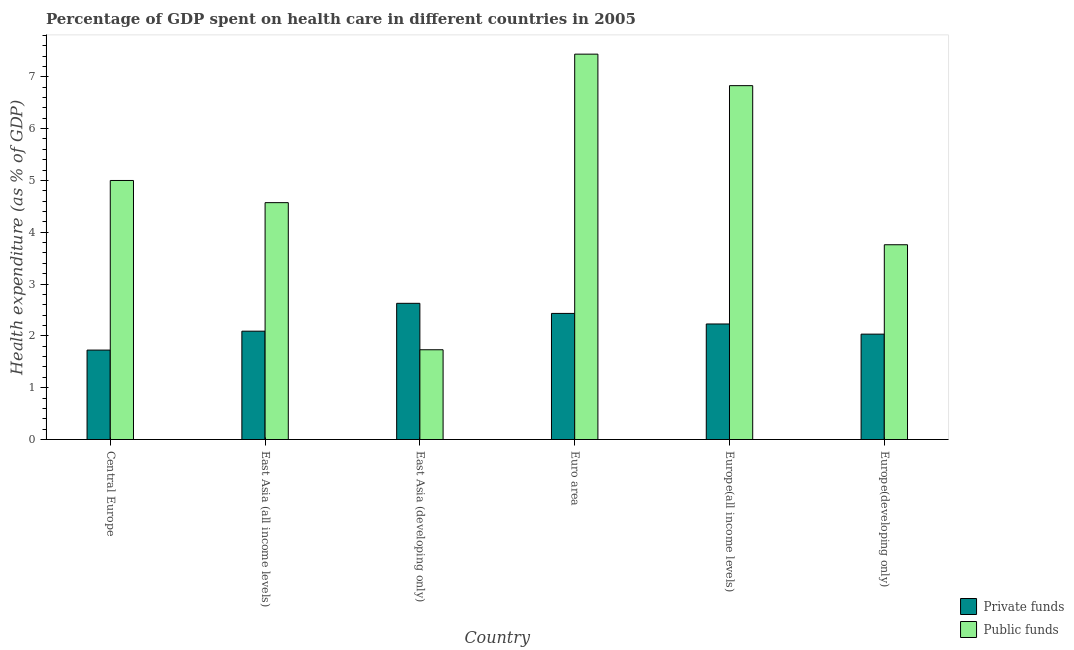How many different coloured bars are there?
Offer a terse response. 2. How many bars are there on the 1st tick from the right?
Make the answer very short. 2. What is the label of the 5th group of bars from the left?
Offer a very short reply. Europe(all income levels). In how many cases, is the number of bars for a given country not equal to the number of legend labels?
Your response must be concise. 0. What is the amount of public funds spent in healthcare in Europe(all income levels)?
Your answer should be compact. 6.83. Across all countries, what is the maximum amount of public funds spent in healthcare?
Give a very brief answer. 7.44. Across all countries, what is the minimum amount of private funds spent in healthcare?
Your answer should be very brief. 1.73. In which country was the amount of private funds spent in healthcare maximum?
Offer a very short reply. East Asia (developing only). In which country was the amount of private funds spent in healthcare minimum?
Ensure brevity in your answer.  Central Europe. What is the total amount of public funds spent in healthcare in the graph?
Make the answer very short. 29.33. What is the difference between the amount of private funds spent in healthcare in Central Europe and that in Europe(all income levels)?
Keep it short and to the point. -0.5. What is the difference between the amount of private funds spent in healthcare in East Asia (developing only) and the amount of public funds spent in healthcare in Central Europe?
Your response must be concise. -2.37. What is the average amount of public funds spent in healthcare per country?
Your answer should be very brief. 4.89. What is the difference between the amount of private funds spent in healthcare and amount of public funds spent in healthcare in East Asia (all income levels)?
Make the answer very short. -2.48. What is the ratio of the amount of public funds spent in healthcare in East Asia (developing only) to that in Europe(all income levels)?
Give a very brief answer. 0.25. Is the amount of private funds spent in healthcare in Central Europe less than that in Euro area?
Your response must be concise. Yes. Is the difference between the amount of public funds spent in healthcare in Europe(all income levels) and Europe(developing only) greater than the difference between the amount of private funds spent in healthcare in Europe(all income levels) and Europe(developing only)?
Offer a terse response. Yes. What is the difference between the highest and the second highest amount of private funds spent in healthcare?
Your answer should be compact. 0.19. What is the difference between the highest and the lowest amount of public funds spent in healthcare?
Your answer should be compact. 5.71. What does the 2nd bar from the left in Europe(all income levels) represents?
Provide a short and direct response. Public funds. What does the 1st bar from the right in Euro area represents?
Your answer should be very brief. Public funds. How many countries are there in the graph?
Give a very brief answer. 6. What is the difference between two consecutive major ticks on the Y-axis?
Provide a short and direct response. 1. Does the graph contain any zero values?
Give a very brief answer. No. Does the graph contain grids?
Give a very brief answer. No. Where does the legend appear in the graph?
Offer a very short reply. Bottom right. What is the title of the graph?
Make the answer very short. Percentage of GDP spent on health care in different countries in 2005. What is the label or title of the X-axis?
Make the answer very short. Country. What is the label or title of the Y-axis?
Make the answer very short. Health expenditure (as % of GDP). What is the Health expenditure (as % of GDP) in Private funds in Central Europe?
Your answer should be compact. 1.73. What is the Health expenditure (as % of GDP) in Public funds in Central Europe?
Provide a succinct answer. 5. What is the Health expenditure (as % of GDP) in Private funds in East Asia (all income levels)?
Provide a succinct answer. 2.09. What is the Health expenditure (as % of GDP) of Public funds in East Asia (all income levels)?
Ensure brevity in your answer.  4.57. What is the Health expenditure (as % of GDP) in Private funds in East Asia (developing only)?
Make the answer very short. 2.63. What is the Health expenditure (as % of GDP) in Public funds in East Asia (developing only)?
Make the answer very short. 1.73. What is the Health expenditure (as % of GDP) of Private funds in Euro area?
Offer a terse response. 2.43. What is the Health expenditure (as % of GDP) in Public funds in Euro area?
Provide a short and direct response. 7.44. What is the Health expenditure (as % of GDP) in Private funds in Europe(all income levels)?
Ensure brevity in your answer.  2.23. What is the Health expenditure (as % of GDP) in Public funds in Europe(all income levels)?
Your response must be concise. 6.83. What is the Health expenditure (as % of GDP) in Private funds in Europe(developing only)?
Provide a succinct answer. 2.03. What is the Health expenditure (as % of GDP) in Public funds in Europe(developing only)?
Keep it short and to the point. 3.76. Across all countries, what is the maximum Health expenditure (as % of GDP) in Private funds?
Offer a terse response. 2.63. Across all countries, what is the maximum Health expenditure (as % of GDP) of Public funds?
Provide a short and direct response. 7.44. Across all countries, what is the minimum Health expenditure (as % of GDP) in Private funds?
Offer a very short reply. 1.73. Across all countries, what is the minimum Health expenditure (as % of GDP) in Public funds?
Ensure brevity in your answer.  1.73. What is the total Health expenditure (as % of GDP) of Private funds in the graph?
Offer a very short reply. 13.14. What is the total Health expenditure (as % of GDP) in Public funds in the graph?
Provide a succinct answer. 29.33. What is the difference between the Health expenditure (as % of GDP) of Private funds in Central Europe and that in East Asia (all income levels)?
Offer a terse response. -0.36. What is the difference between the Health expenditure (as % of GDP) of Public funds in Central Europe and that in East Asia (all income levels)?
Give a very brief answer. 0.43. What is the difference between the Health expenditure (as % of GDP) in Private funds in Central Europe and that in East Asia (developing only)?
Ensure brevity in your answer.  -0.9. What is the difference between the Health expenditure (as % of GDP) of Public funds in Central Europe and that in East Asia (developing only)?
Provide a short and direct response. 3.27. What is the difference between the Health expenditure (as % of GDP) in Private funds in Central Europe and that in Euro area?
Your answer should be very brief. -0.71. What is the difference between the Health expenditure (as % of GDP) in Public funds in Central Europe and that in Euro area?
Your answer should be compact. -2.44. What is the difference between the Health expenditure (as % of GDP) in Private funds in Central Europe and that in Europe(all income levels)?
Your answer should be compact. -0.5. What is the difference between the Health expenditure (as % of GDP) of Public funds in Central Europe and that in Europe(all income levels)?
Keep it short and to the point. -1.83. What is the difference between the Health expenditure (as % of GDP) of Private funds in Central Europe and that in Europe(developing only)?
Your answer should be very brief. -0.31. What is the difference between the Health expenditure (as % of GDP) in Public funds in Central Europe and that in Europe(developing only)?
Provide a short and direct response. 1.24. What is the difference between the Health expenditure (as % of GDP) in Private funds in East Asia (all income levels) and that in East Asia (developing only)?
Give a very brief answer. -0.54. What is the difference between the Health expenditure (as % of GDP) in Public funds in East Asia (all income levels) and that in East Asia (developing only)?
Give a very brief answer. 2.84. What is the difference between the Health expenditure (as % of GDP) in Private funds in East Asia (all income levels) and that in Euro area?
Provide a short and direct response. -0.34. What is the difference between the Health expenditure (as % of GDP) of Public funds in East Asia (all income levels) and that in Euro area?
Make the answer very short. -2.87. What is the difference between the Health expenditure (as % of GDP) in Private funds in East Asia (all income levels) and that in Europe(all income levels)?
Your answer should be compact. -0.14. What is the difference between the Health expenditure (as % of GDP) in Public funds in East Asia (all income levels) and that in Europe(all income levels)?
Provide a short and direct response. -2.26. What is the difference between the Health expenditure (as % of GDP) in Private funds in East Asia (all income levels) and that in Europe(developing only)?
Your response must be concise. 0.06. What is the difference between the Health expenditure (as % of GDP) of Public funds in East Asia (all income levels) and that in Europe(developing only)?
Provide a short and direct response. 0.81. What is the difference between the Health expenditure (as % of GDP) in Private funds in East Asia (developing only) and that in Euro area?
Your response must be concise. 0.19. What is the difference between the Health expenditure (as % of GDP) in Public funds in East Asia (developing only) and that in Euro area?
Your answer should be very brief. -5.71. What is the difference between the Health expenditure (as % of GDP) in Private funds in East Asia (developing only) and that in Europe(all income levels)?
Provide a succinct answer. 0.4. What is the difference between the Health expenditure (as % of GDP) in Public funds in East Asia (developing only) and that in Europe(all income levels)?
Keep it short and to the point. -5.1. What is the difference between the Health expenditure (as % of GDP) in Private funds in East Asia (developing only) and that in Europe(developing only)?
Provide a short and direct response. 0.59. What is the difference between the Health expenditure (as % of GDP) of Public funds in East Asia (developing only) and that in Europe(developing only)?
Provide a short and direct response. -2.03. What is the difference between the Health expenditure (as % of GDP) of Private funds in Euro area and that in Europe(all income levels)?
Provide a succinct answer. 0.2. What is the difference between the Health expenditure (as % of GDP) in Public funds in Euro area and that in Europe(all income levels)?
Your answer should be compact. 0.61. What is the difference between the Health expenditure (as % of GDP) in Private funds in Euro area and that in Europe(developing only)?
Ensure brevity in your answer.  0.4. What is the difference between the Health expenditure (as % of GDP) in Public funds in Euro area and that in Europe(developing only)?
Your response must be concise. 3.68. What is the difference between the Health expenditure (as % of GDP) in Private funds in Europe(all income levels) and that in Europe(developing only)?
Make the answer very short. 0.2. What is the difference between the Health expenditure (as % of GDP) in Public funds in Europe(all income levels) and that in Europe(developing only)?
Keep it short and to the point. 3.07. What is the difference between the Health expenditure (as % of GDP) in Private funds in Central Europe and the Health expenditure (as % of GDP) in Public funds in East Asia (all income levels)?
Make the answer very short. -2.85. What is the difference between the Health expenditure (as % of GDP) of Private funds in Central Europe and the Health expenditure (as % of GDP) of Public funds in East Asia (developing only)?
Your response must be concise. -0.01. What is the difference between the Health expenditure (as % of GDP) in Private funds in Central Europe and the Health expenditure (as % of GDP) in Public funds in Euro area?
Provide a succinct answer. -5.71. What is the difference between the Health expenditure (as % of GDP) of Private funds in Central Europe and the Health expenditure (as % of GDP) of Public funds in Europe(all income levels)?
Offer a very short reply. -5.1. What is the difference between the Health expenditure (as % of GDP) in Private funds in Central Europe and the Health expenditure (as % of GDP) in Public funds in Europe(developing only)?
Your response must be concise. -2.03. What is the difference between the Health expenditure (as % of GDP) in Private funds in East Asia (all income levels) and the Health expenditure (as % of GDP) in Public funds in East Asia (developing only)?
Your response must be concise. 0.36. What is the difference between the Health expenditure (as % of GDP) in Private funds in East Asia (all income levels) and the Health expenditure (as % of GDP) in Public funds in Euro area?
Offer a terse response. -5.35. What is the difference between the Health expenditure (as % of GDP) of Private funds in East Asia (all income levels) and the Health expenditure (as % of GDP) of Public funds in Europe(all income levels)?
Your answer should be very brief. -4.74. What is the difference between the Health expenditure (as % of GDP) of Private funds in East Asia (all income levels) and the Health expenditure (as % of GDP) of Public funds in Europe(developing only)?
Make the answer very short. -1.67. What is the difference between the Health expenditure (as % of GDP) of Private funds in East Asia (developing only) and the Health expenditure (as % of GDP) of Public funds in Euro area?
Ensure brevity in your answer.  -4.81. What is the difference between the Health expenditure (as % of GDP) of Private funds in East Asia (developing only) and the Health expenditure (as % of GDP) of Public funds in Europe(all income levels)?
Keep it short and to the point. -4.2. What is the difference between the Health expenditure (as % of GDP) in Private funds in East Asia (developing only) and the Health expenditure (as % of GDP) in Public funds in Europe(developing only)?
Provide a short and direct response. -1.13. What is the difference between the Health expenditure (as % of GDP) of Private funds in Euro area and the Health expenditure (as % of GDP) of Public funds in Europe(all income levels)?
Give a very brief answer. -4.4. What is the difference between the Health expenditure (as % of GDP) in Private funds in Euro area and the Health expenditure (as % of GDP) in Public funds in Europe(developing only)?
Make the answer very short. -1.33. What is the difference between the Health expenditure (as % of GDP) in Private funds in Europe(all income levels) and the Health expenditure (as % of GDP) in Public funds in Europe(developing only)?
Your answer should be compact. -1.53. What is the average Health expenditure (as % of GDP) in Private funds per country?
Ensure brevity in your answer.  2.19. What is the average Health expenditure (as % of GDP) in Public funds per country?
Keep it short and to the point. 4.89. What is the difference between the Health expenditure (as % of GDP) in Private funds and Health expenditure (as % of GDP) in Public funds in Central Europe?
Give a very brief answer. -3.27. What is the difference between the Health expenditure (as % of GDP) in Private funds and Health expenditure (as % of GDP) in Public funds in East Asia (all income levels)?
Keep it short and to the point. -2.48. What is the difference between the Health expenditure (as % of GDP) in Private funds and Health expenditure (as % of GDP) in Public funds in East Asia (developing only)?
Provide a short and direct response. 0.9. What is the difference between the Health expenditure (as % of GDP) in Private funds and Health expenditure (as % of GDP) in Public funds in Euro area?
Ensure brevity in your answer.  -5. What is the difference between the Health expenditure (as % of GDP) in Private funds and Health expenditure (as % of GDP) in Public funds in Europe(all income levels)?
Make the answer very short. -4.6. What is the difference between the Health expenditure (as % of GDP) in Private funds and Health expenditure (as % of GDP) in Public funds in Europe(developing only)?
Give a very brief answer. -1.73. What is the ratio of the Health expenditure (as % of GDP) in Private funds in Central Europe to that in East Asia (all income levels)?
Keep it short and to the point. 0.83. What is the ratio of the Health expenditure (as % of GDP) in Public funds in Central Europe to that in East Asia (all income levels)?
Your response must be concise. 1.09. What is the ratio of the Health expenditure (as % of GDP) in Private funds in Central Europe to that in East Asia (developing only)?
Offer a terse response. 0.66. What is the ratio of the Health expenditure (as % of GDP) in Public funds in Central Europe to that in East Asia (developing only)?
Ensure brevity in your answer.  2.89. What is the ratio of the Health expenditure (as % of GDP) of Private funds in Central Europe to that in Euro area?
Keep it short and to the point. 0.71. What is the ratio of the Health expenditure (as % of GDP) of Public funds in Central Europe to that in Euro area?
Provide a succinct answer. 0.67. What is the ratio of the Health expenditure (as % of GDP) of Private funds in Central Europe to that in Europe(all income levels)?
Your response must be concise. 0.77. What is the ratio of the Health expenditure (as % of GDP) in Public funds in Central Europe to that in Europe(all income levels)?
Your answer should be compact. 0.73. What is the ratio of the Health expenditure (as % of GDP) in Private funds in Central Europe to that in Europe(developing only)?
Offer a terse response. 0.85. What is the ratio of the Health expenditure (as % of GDP) of Public funds in Central Europe to that in Europe(developing only)?
Provide a short and direct response. 1.33. What is the ratio of the Health expenditure (as % of GDP) in Private funds in East Asia (all income levels) to that in East Asia (developing only)?
Make the answer very short. 0.8. What is the ratio of the Health expenditure (as % of GDP) of Public funds in East Asia (all income levels) to that in East Asia (developing only)?
Your answer should be compact. 2.64. What is the ratio of the Health expenditure (as % of GDP) of Private funds in East Asia (all income levels) to that in Euro area?
Give a very brief answer. 0.86. What is the ratio of the Health expenditure (as % of GDP) in Public funds in East Asia (all income levels) to that in Euro area?
Ensure brevity in your answer.  0.61. What is the ratio of the Health expenditure (as % of GDP) in Private funds in East Asia (all income levels) to that in Europe(all income levels)?
Your answer should be very brief. 0.94. What is the ratio of the Health expenditure (as % of GDP) of Public funds in East Asia (all income levels) to that in Europe(all income levels)?
Your answer should be very brief. 0.67. What is the ratio of the Health expenditure (as % of GDP) in Private funds in East Asia (all income levels) to that in Europe(developing only)?
Keep it short and to the point. 1.03. What is the ratio of the Health expenditure (as % of GDP) of Public funds in East Asia (all income levels) to that in Europe(developing only)?
Offer a very short reply. 1.22. What is the ratio of the Health expenditure (as % of GDP) of Private funds in East Asia (developing only) to that in Euro area?
Your answer should be very brief. 1.08. What is the ratio of the Health expenditure (as % of GDP) of Public funds in East Asia (developing only) to that in Euro area?
Your answer should be very brief. 0.23. What is the ratio of the Health expenditure (as % of GDP) in Private funds in East Asia (developing only) to that in Europe(all income levels)?
Ensure brevity in your answer.  1.18. What is the ratio of the Health expenditure (as % of GDP) of Public funds in East Asia (developing only) to that in Europe(all income levels)?
Provide a short and direct response. 0.25. What is the ratio of the Health expenditure (as % of GDP) of Private funds in East Asia (developing only) to that in Europe(developing only)?
Your response must be concise. 1.29. What is the ratio of the Health expenditure (as % of GDP) of Public funds in East Asia (developing only) to that in Europe(developing only)?
Give a very brief answer. 0.46. What is the ratio of the Health expenditure (as % of GDP) of Private funds in Euro area to that in Europe(all income levels)?
Your answer should be compact. 1.09. What is the ratio of the Health expenditure (as % of GDP) of Public funds in Euro area to that in Europe(all income levels)?
Offer a terse response. 1.09. What is the ratio of the Health expenditure (as % of GDP) of Private funds in Euro area to that in Europe(developing only)?
Provide a short and direct response. 1.2. What is the ratio of the Health expenditure (as % of GDP) of Public funds in Euro area to that in Europe(developing only)?
Ensure brevity in your answer.  1.98. What is the ratio of the Health expenditure (as % of GDP) in Private funds in Europe(all income levels) to that in Europe(developing only)?
Offer a terse response. 1.1. What is the ratio of the Health expenditure (as % of GDP) of Public funds in Europe(all income levels) to that in Europe(developing only)?
Give a very brief answer. 1.82. What is the difference between the highest and the second highest Health expenditure (as % of GDP) in Private funds?
Make the answer very short. 0.19. What is the difference between the highest and the second highest Health expenditure (as % of GDP) in Public funds?
Offer a very short reply. 0.61. What is the difference between the highest and the lowest Health expenditure (as % of GDP) in Private funds?
Offer a terse response. 0.9. What is the difference between the highest and the lowest Health expenditure (as % of GDP) in Public funds?
Ensure brevity in your answer.  5.71. 